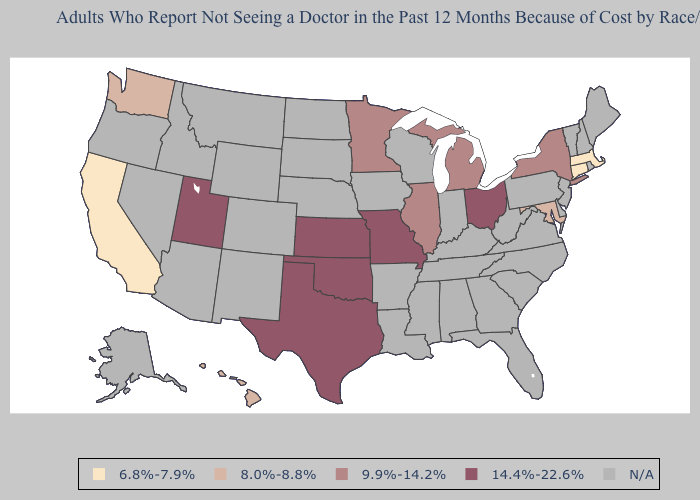Is the legend a continuous bar?
Write a very short answer. No. Does Kansas have the highest value in the USA?
Short answer required. Yes. Is the legend a continuous bar?
Write a very short answer. No. Does Oklahoma have the lowest value in the South?
Be succinct. No. What is the lowest value in the MidWest?
Quick response, please. 9.9%-14.2%. What is the lowest value in states that border New York?
Write a very short answer. 6.8%-7.9%. Does Washington have the highest value in the USA?
Write a very short answer. No. Name the states that have a value in the range 6.8%-7.9%?
Short answer required. California, Connecticut, Massachusetts. Among the states that border Tennessee , which have the lowest value?
Short answer required. Missouri. What is the value of Missouri?
Answer briefly. 14.4%-22.6%. Does Hawaii have the highest value in the USA?
Answer briefly. No. Name the states that have a value in the range N/A?
Short answer required. Alabama, Alaska, Arizona, Arkansas, Colorado, Delaware, Florida, Georgia, Idaho, Indiana, Iowa, Kentucky, Louisiana, Maine, Mississippi, Montana, Nebraska, Nevada, New Hampshire, New Jersey, New Mexico, North Carolina, North Dakota, Oregon, Pennsylvania, Rhode Island, South Carolina, South Dakota, Tennessee, Vermont, Virginia, West Virginia, Wisconsin, Wyoming. Does the first symbol in the legend represent the smallest category?
Be succinct. Yes. 